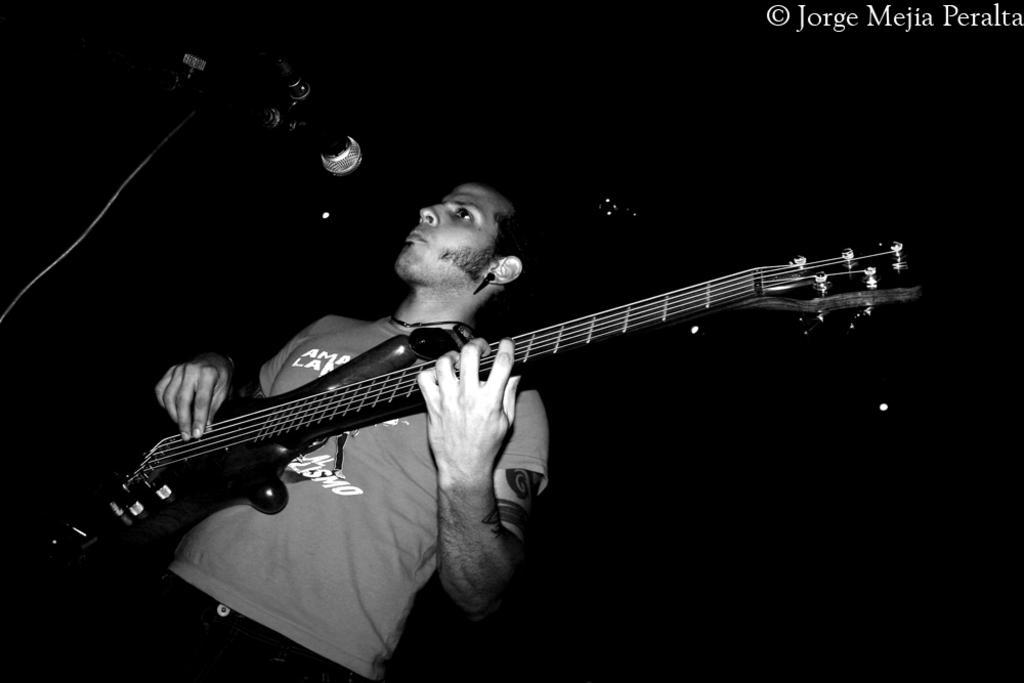Could you give a brief overview of what you see in this image? This is a black and white image. In the middle of this image, there is a person with a T-shirt, standing, holding guitar and playing in front of a mess which is attached to a stand. In the background, there are lights arranged. And the background is dark in color. 